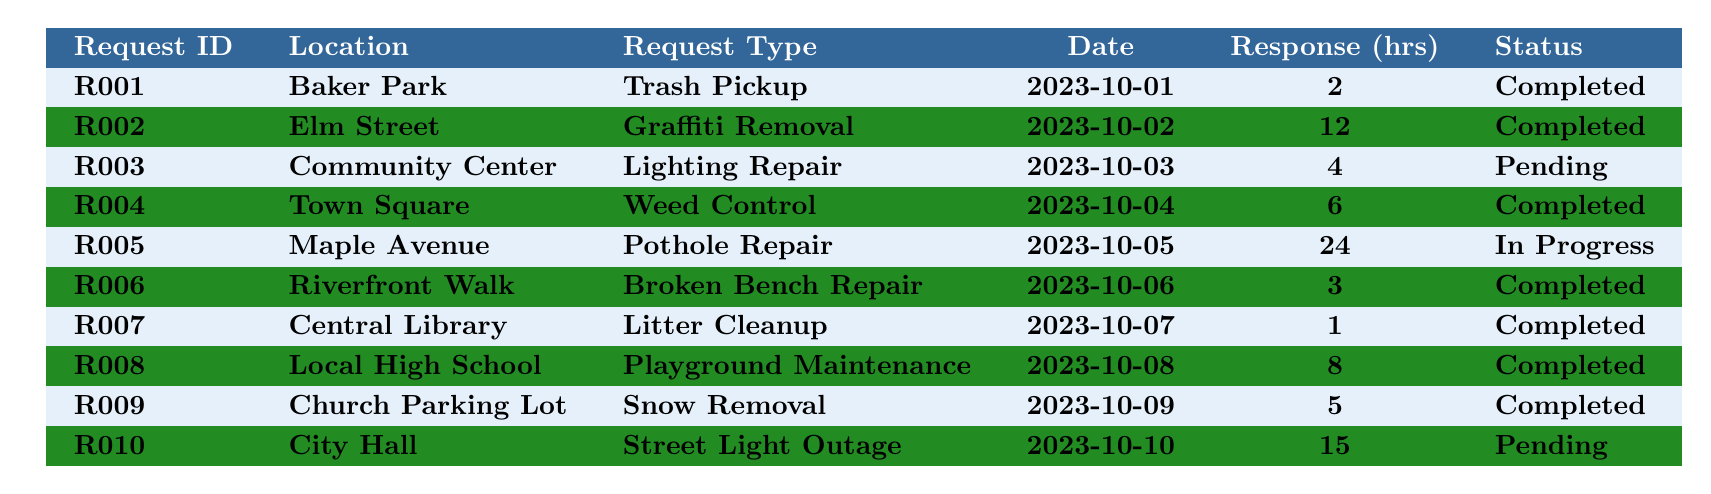What is the location of the request with ID R006? The table shows that the request with ID R006 is listed under the "Location" column as "Riverfront Walk."
Answer: Riverfront Walk How many requests are marked as "Completed"? I can count the number of requests with the status "Completed" in the table. There are 7 requests that have this status: R001, R002, R004, R006, R007, R008, R009.
Answer: 7 What type of request was made at the Local High School? Referring to the table, the request at the Local High School is categorized under "Request Type" as "Playground Maintenance."
Answer: Playground Maintenance What was the response time for the Pothole Repair request on Maple Avenue? The table shows that the response time for the Pothole Repair request (RequestID R005) at Maple Avenue is 24 hours.
Answer: 24 hours Are there any pending requests? By looking at the status column, I see that there are two requests with the status "Pending": R003 (Lighting Repair at Community Center) and R010 (Street Light Outage at City Hall).
Answer: Yes Which request took the longest response time, and where was it located? I will look through the response times listed in the "Response (hrs)" column and identify that the longest one is 24 hours for the request ID R005, located at Maple Avenue for Pothole Repair.
Answer: Maple Avenue What is the average response time for completed requests? To calculate the average response time for completed requests, I first list the corresponding response times: 2, 12, 6, 3, 1, 8, 5. The total sum is 37, and there are 7 completed requests. Therefore, I divide 37 by 7 to get approximately 5.29.
Answer: Approximately 5.29 hours How many hours faster was the Litter Cleanup request completed compared to the Graffiti Removal request? Looking at the response times in the table, Litter Cleanup response time is 1 hour (R007) and Graffiti Removal response time is 12 hours (R002). The difference in response times is 12 - 1 = 11 hours faster.
Answer: 11 hours What is the status of the request for Lighting Repair, and when was it made? The table indicates that the status of the Lighting Repair request (R003) is "Pending," and the request date is "2023-10-03."
Answer: Pending; 2023-10-03 How many requests were completed on or after October 5th? I will check the request dates in the table. The completed requests on or after October 5th are R005 (Pothole Repair), R006 (Broken Bench Repair), R007 (Litter Cleanup), R008 (Playground Maintenance), and R009 (Snow Removal), totaling 5 requests.
Answer: 5 requests 